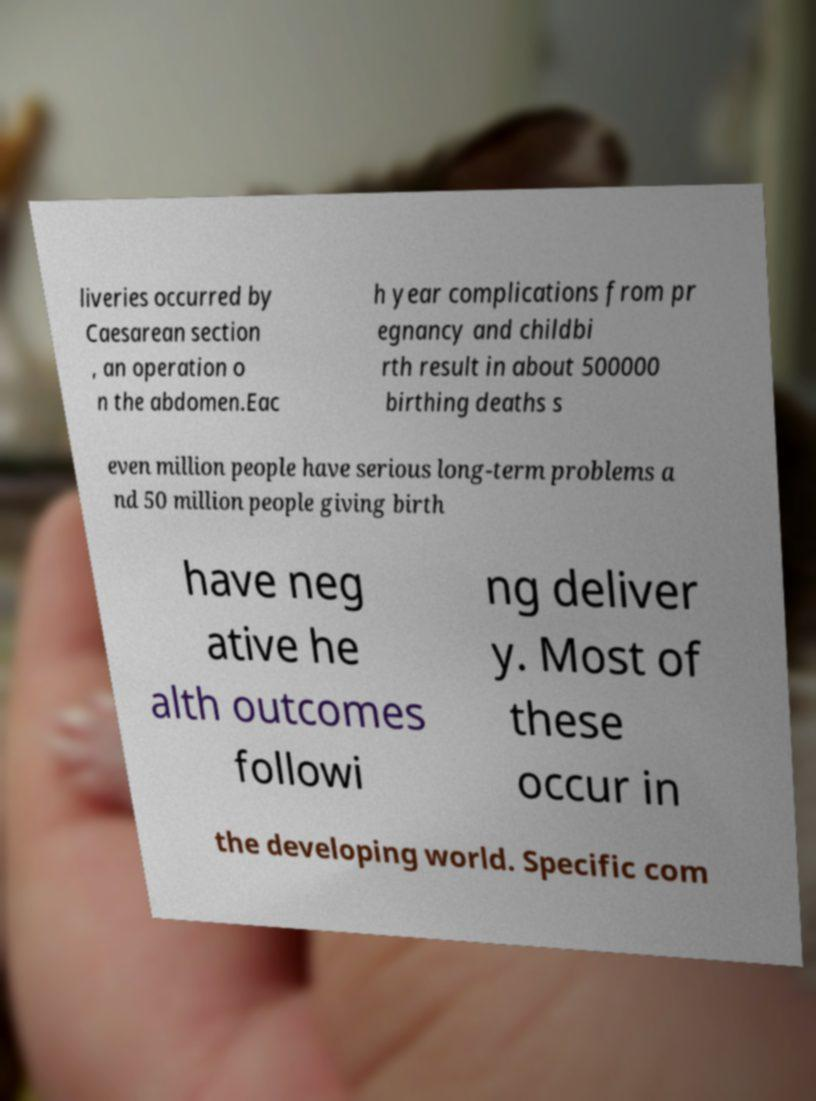I need the written content from this picture converted into text. Can you do that? liveries occurred by Caesarean section , an operation o n the abdomen.Eac h year complications from pr egnancy and childbi rth result in about 500000 birthing deaths s even million people have serious long-term problems a nd 50 million people giving birth have neg ative he alth outcomes followi ng deliver y. Most of these occur in the developing world. Specific com 